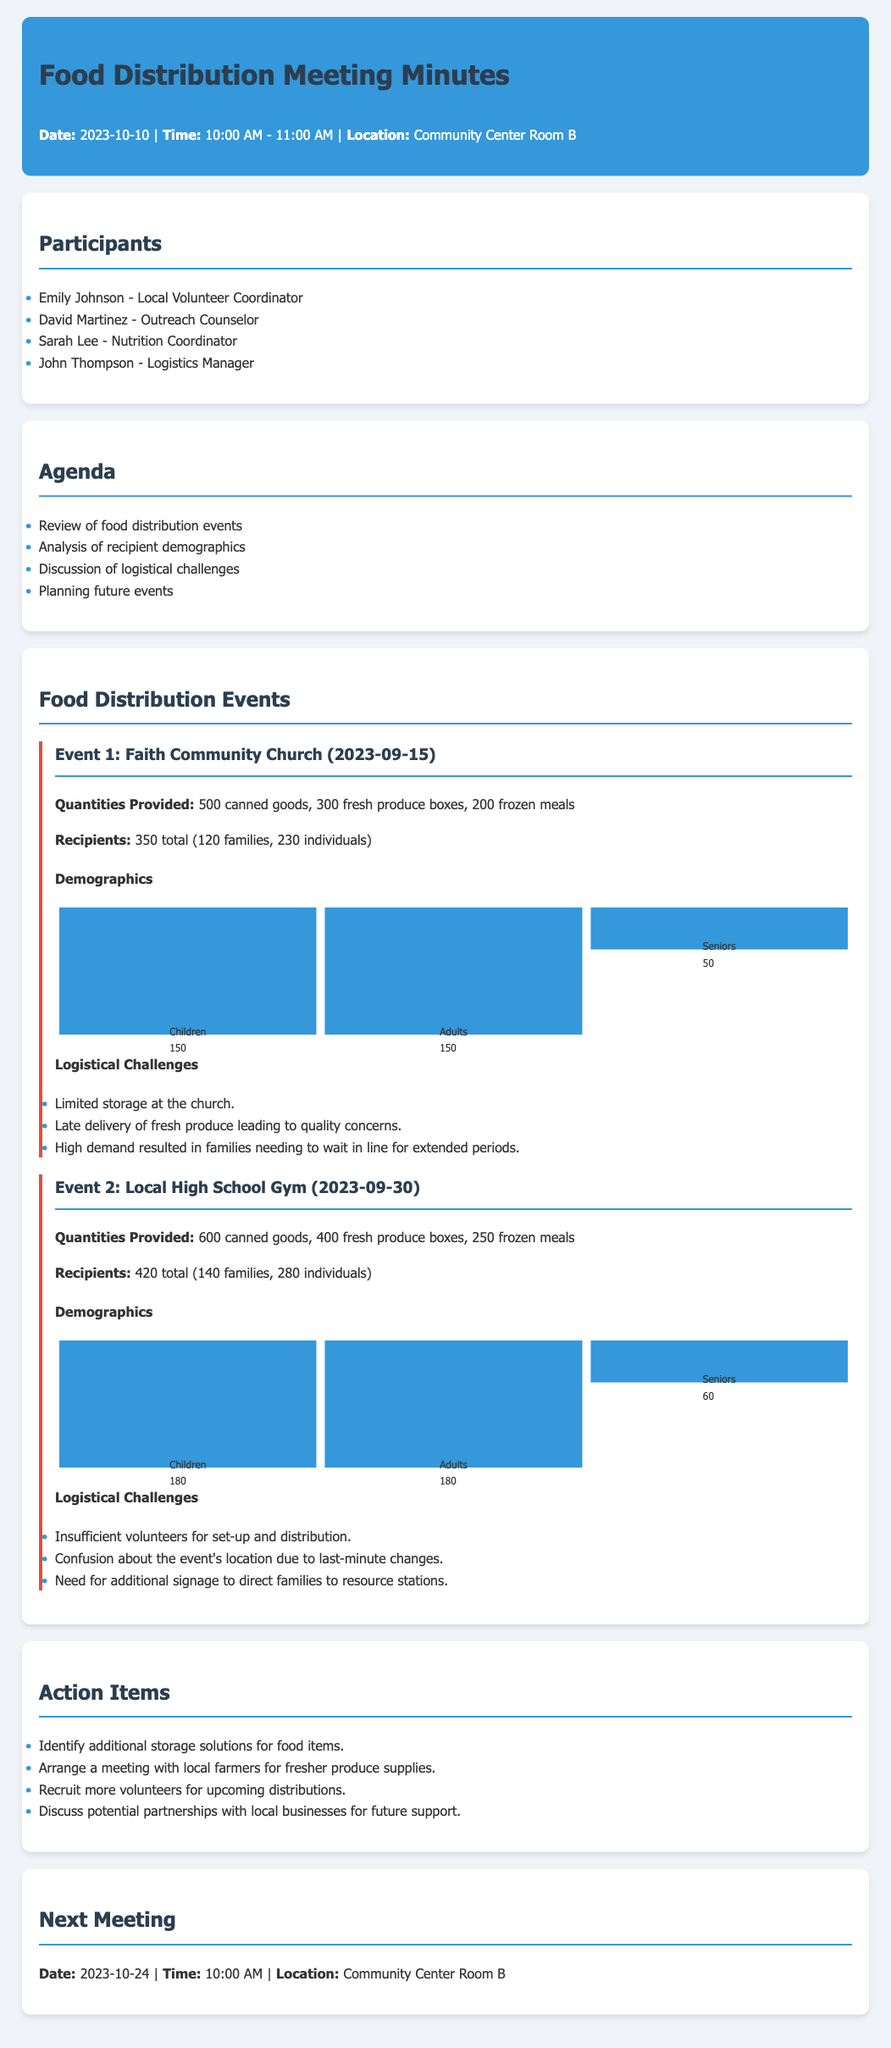what is the date of the meeting? The date of the meeting is mentioned in the document's header, which states it is on 2023-10-10.
Answer: 2023-10-10 how many families received food at Event 1? Event 1 details indicate that 120 families received food.
Answer: 120 families what were the total recipients at Event 2? According to the document, Event 2 had a total of 420 recipients.
Answer: 420 what logistical challenge was faced during Event 1? The document lists limited storage at the church as a logistical challenge for Event 1.
Answer: Limited storage at the church how many canned goods were provided at Event 2? The quantities provided in Event 2 include 600 canned goods, as stated in the document.
Answer: 600 canned goods what is the next meeting date? The document specifies the next meeting date as 2023-10-24.
Answer: 2023-10-24 what percentage of recipients were seniors at Event 1? The demographics for Event 1 show that 50 seniors out of 350 total recipients equal approximately 14.29%.
Answer: 14.29% what was one reason for confusion at Event 2? The document mentions confusion about the event's location due to last-minute changes.
Answer: Last-minute changes how many total food distribution events are detailed in the minutes? The minutes provide details on two food distribution events organized.
Answer: Two events 